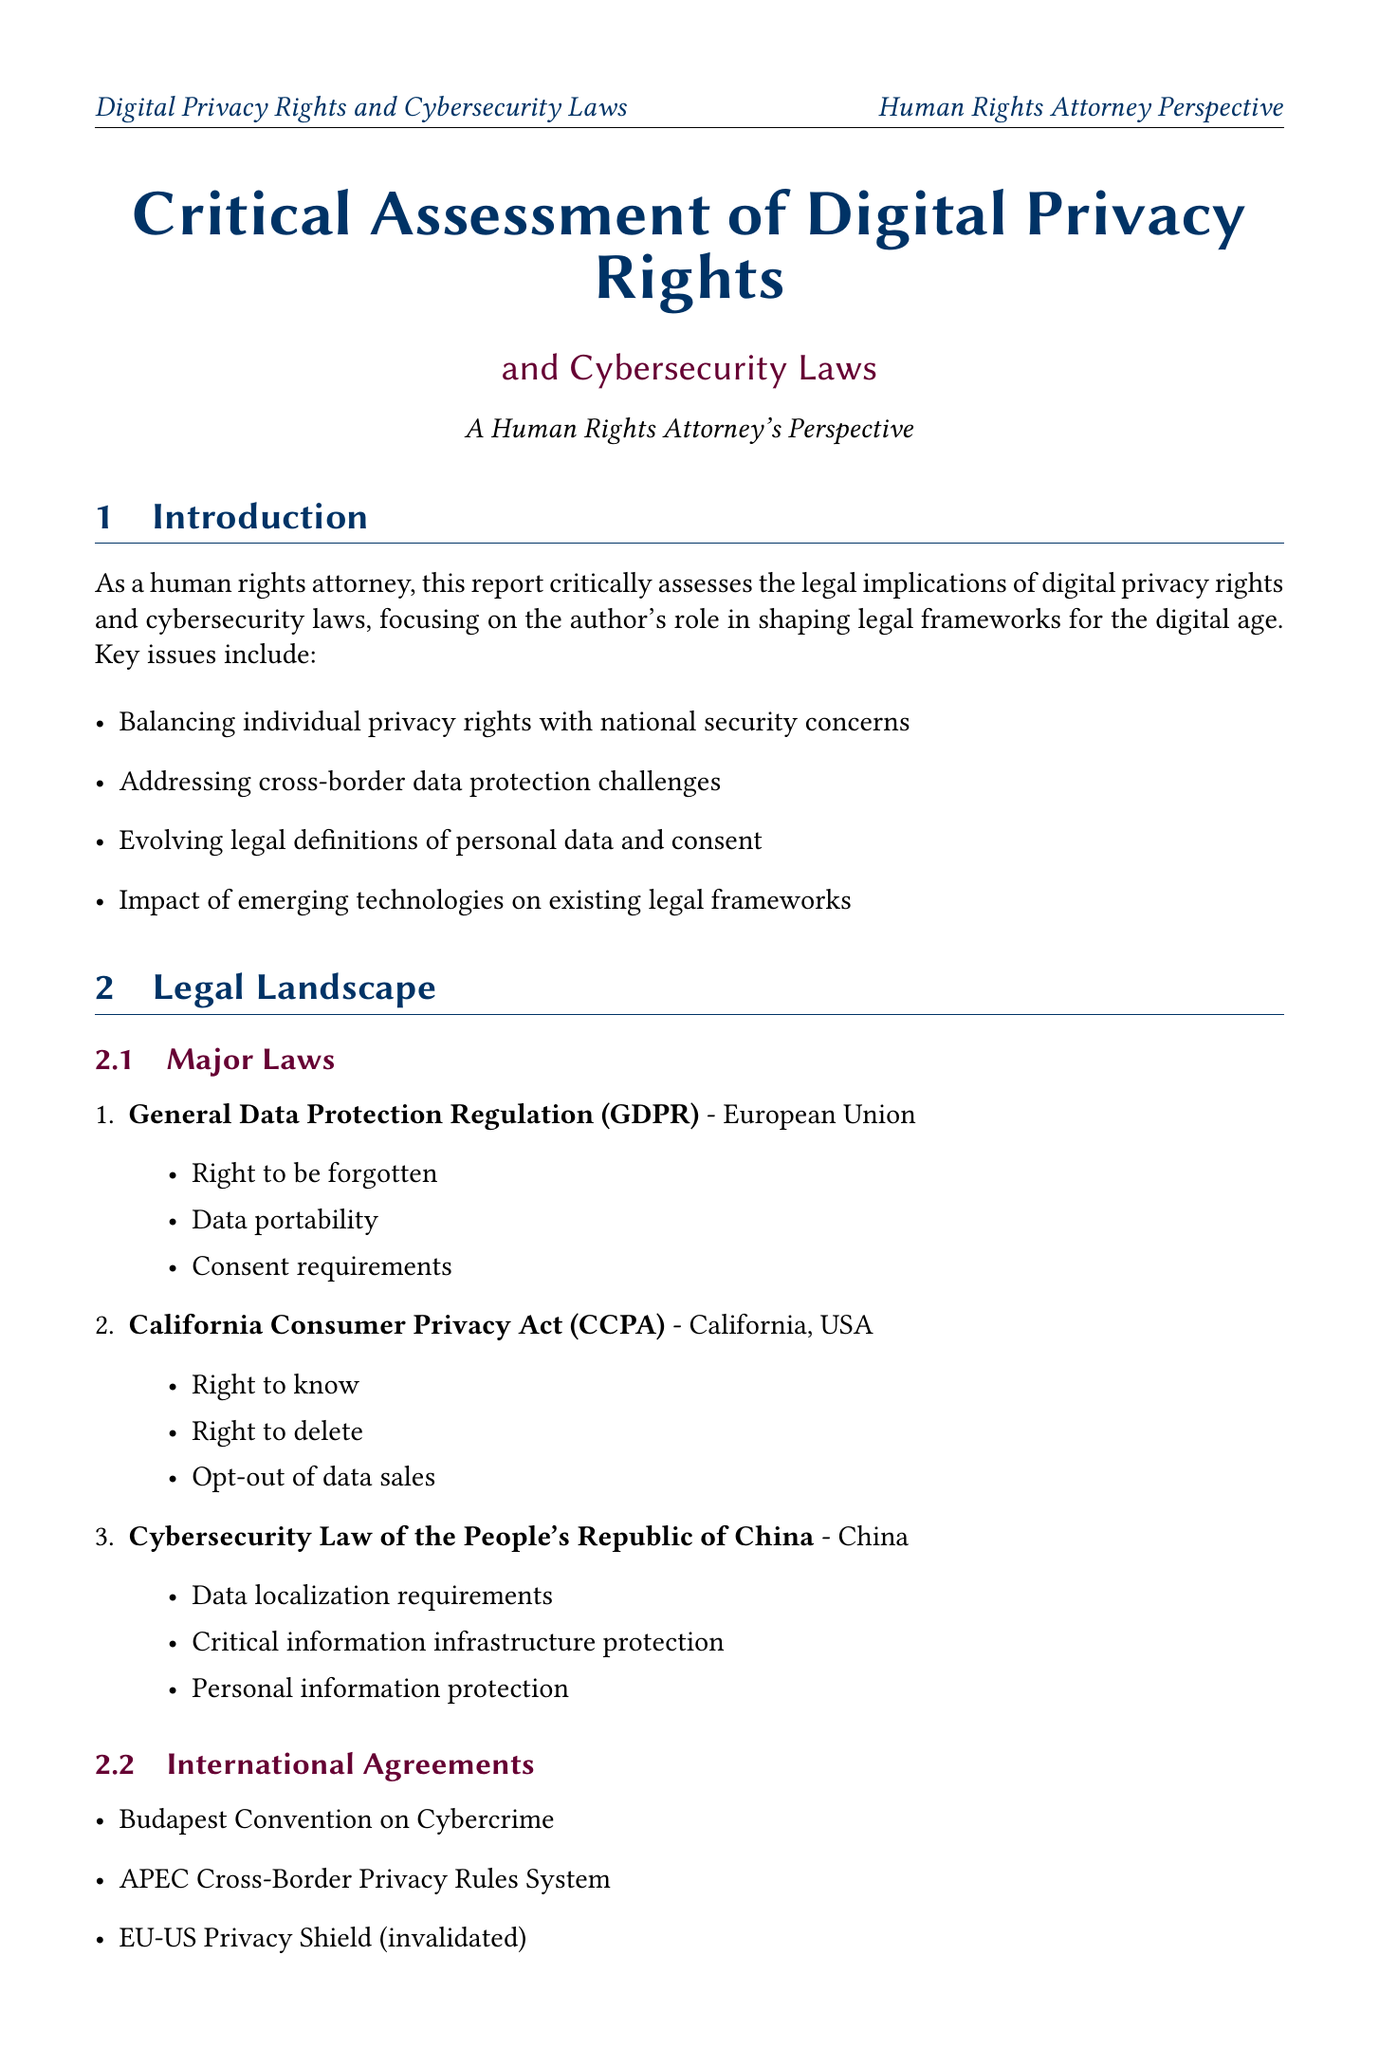What is the main focus of the report? The report critically assesses the legal implications of digital privacy rights and cybersecurity laws, with a focus on the author's role in shaping legal frameworks for the digital age.
Answer: Legal implications of digital privacy rights and cybersecurity laws Which major law includes the 'right to be forgotten'? The 'right to be forgotten' is a key provision of the General Data Protection Regulation (GDPR).
Answer: General Data Protection Regulation (GDPR) What is one of the challenges mentioned in the report? One of the challenges is the rapid technological advancements outpacing legal frameworks.
Answer: Rapid technological advancements Which court ruled on the invalidation of the EU-US Privacy Shield? The court that ruled on this case is the Court of Justice of the European Union.
Answer: Court of Justice of the European Union What is a recommendation provided in the document? One recommendation is to develop technology-neutral legal principles.
Answer: Develop technology-neutral legal principles How many international agreements are listed in the document? There are three international agreements mentioned in the legal landscape section.
Answer: Three What type of activity is the author involved in for public education? The author conducts workshops for legal professionals.
Answer: Conducting workshops for legal professionals What is a future trend mentioned in the report? One future trend is the increased focus on algorithmic transparency and accountability.
Answer: Increased focus on algorithmic transparency and accountability 